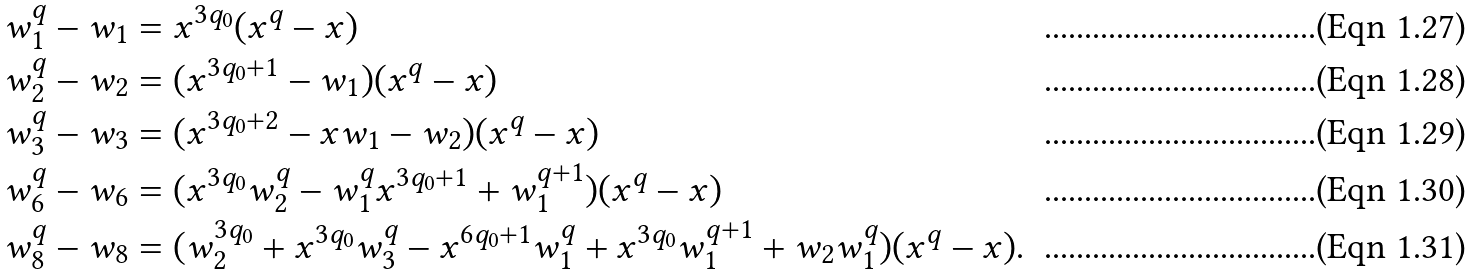Convert formula to latex. <formula><loc_0><loc_0><loc_500><loc_500>w _ { 1 } ^ { q } - w _ { 1 } & = x ^ { 3 q _ { 0 } } ( x ^ { q } - x ) \\ w _ { 2 } ^ { q } - w _ { 2 } & = ( x ^ { 3 q _ { 0 } + 1 } - w _ { 1 } ) ( x ^ { q } - x ) \\ w _ { 3 } ^ { q } - w _ { 3 } & = ( x ^ { 3 q _ { 0 } + 2 } - x w _ { 1 } - w _ { 2 } ) ( x ^ { q } - x ) \\ w _ { 6 } ^ { q } - w _ { 6 } & = ( x ^ { 3 q _ { 0 } } w _ { 2 } ^ { q } - w _ { 1 } ^ { q } x ^ { 3 q _ { 0 } + 1 } + w _ { 1 } ^ { q + 1 } ) ( x ^ { q } - x ) \\ w _ { 8 } ^ { q } - w _ { 8 } & = ( w _ { 2 } ^ { 3 q _ { 0 } } + x ^ { 3 q _ { 0 } } w _ { 3 } ^ { q } - x ^ { 6 q _ { 0 } + 1 } w _ { 1 } ^ { q } + x ^ { 3 q _ { 0 } } w _ { 1 } ^ { q + 1 } + w _ { 2 } w _ { 1 } ^ { q } ) ( x ^ { q } - x ) .</formula> 